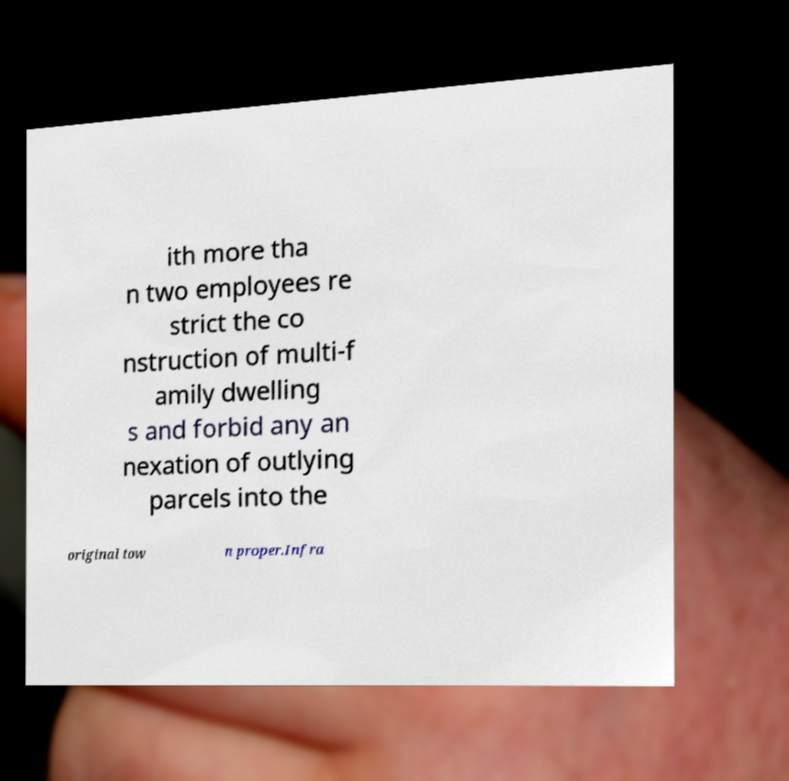Could you extract and type out the text from this image? ith more tha n two employees re strict the co nstruction of multi-f amily dwelling s and forbid any an nexation of outlying parcels into the original tow n proper.Infra 